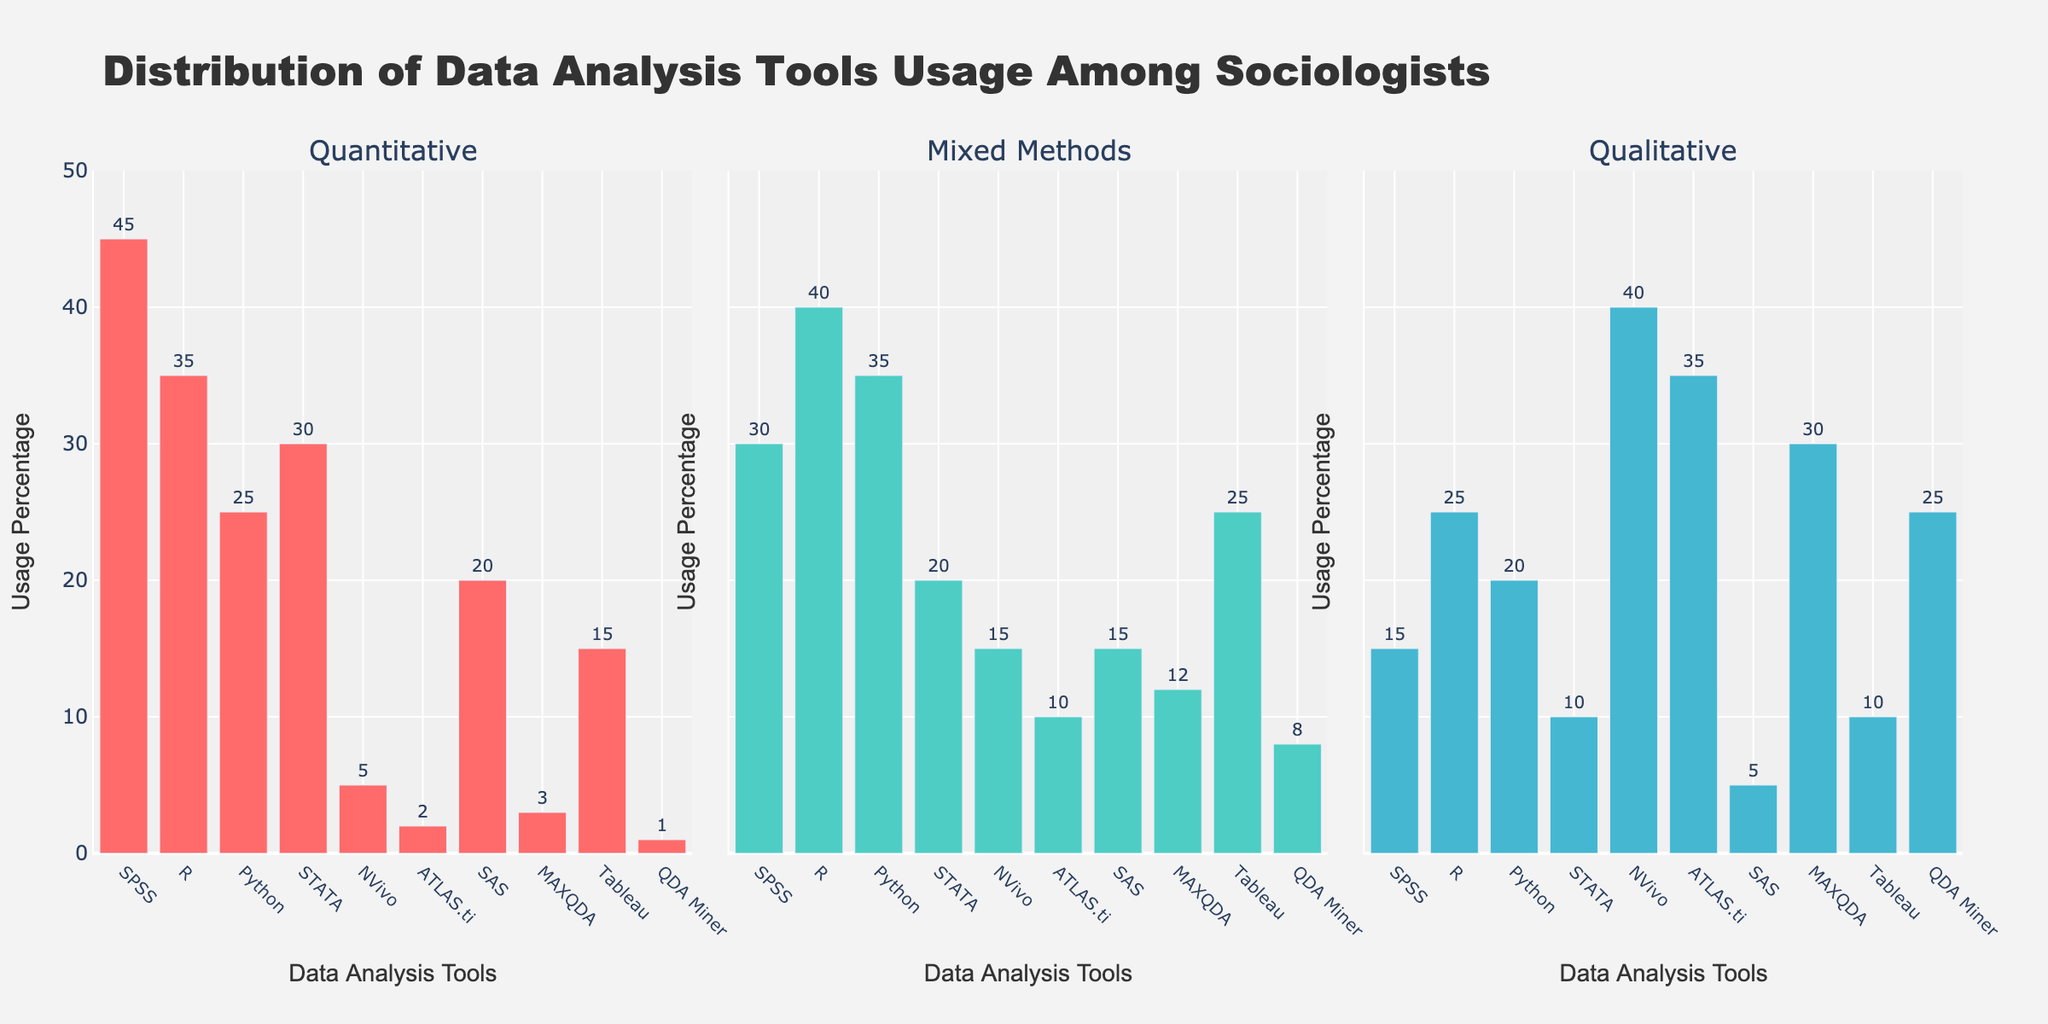what is the title of the figure? The title is clearly displayed at the top of the figure. It summarizes the main point of the data being presented.
Answer: Distribution of Data Analysis Tools Usage Among Sociologists How many categories of research methodologies are represented in the figure? By counting the number of subplot titles, we can see each represents a different category of research methodology: Quantitative, Mixed Methods, Qualitative.
Answer: 3 Which data analysis tool is most used in Quantitative research methodology? Looking at the highest bar in the Quantitative subplot, we see that SPSS has the highest value.
Answer: SPSS What is the least used tool in Mixed Methods research methodology? By identifying the shortest bar in the Mixed Methods subplot, we see that QDA Miner has the lowest value.
Answer: QDA Miner How much more frequently is SPSS used than NVivo in Quantitative research methodology? SPSS has a value of 45, and NVivo has a value of 5. Therefore, the difference is calculated as 45 - 5 = 40.
Answer: 40 Which data analysis tool has the highest usage percentage in Qualitative research methodology? Observing the tallest bar in the Qualitative subplot, we find that NVivo has the highest value.
Answer: NVivo Compare the usage of R in the Quantitative and Mixed Methods research methodologies. Which one is greater? By comparing the height of the R bar in Quantitative (35) to that in Mixed Methods (40), it is clear Mixed Methods has a higher value.
Answer: Mixed Methods What is the total usage percentage of SAS across all research methodologies? Adding the values for SAS across the subplots: 20 (Quantitative) + 15 (Mixed Methods) + 5 (Qualitative) = 40.
Answer: 40 Which data analysis tools are used more in Qualitative research methodology than in Quantitative research methodology? By comparing the heights of bars in the Qualitative and Quantitative subplots, we find NVivo, ATLAS.ti, MAXQDA, and QDA Miner have higher values in Qualitative.
Answer: NVivo, ATLAS.ti, MAXQDA, QDA Miner 